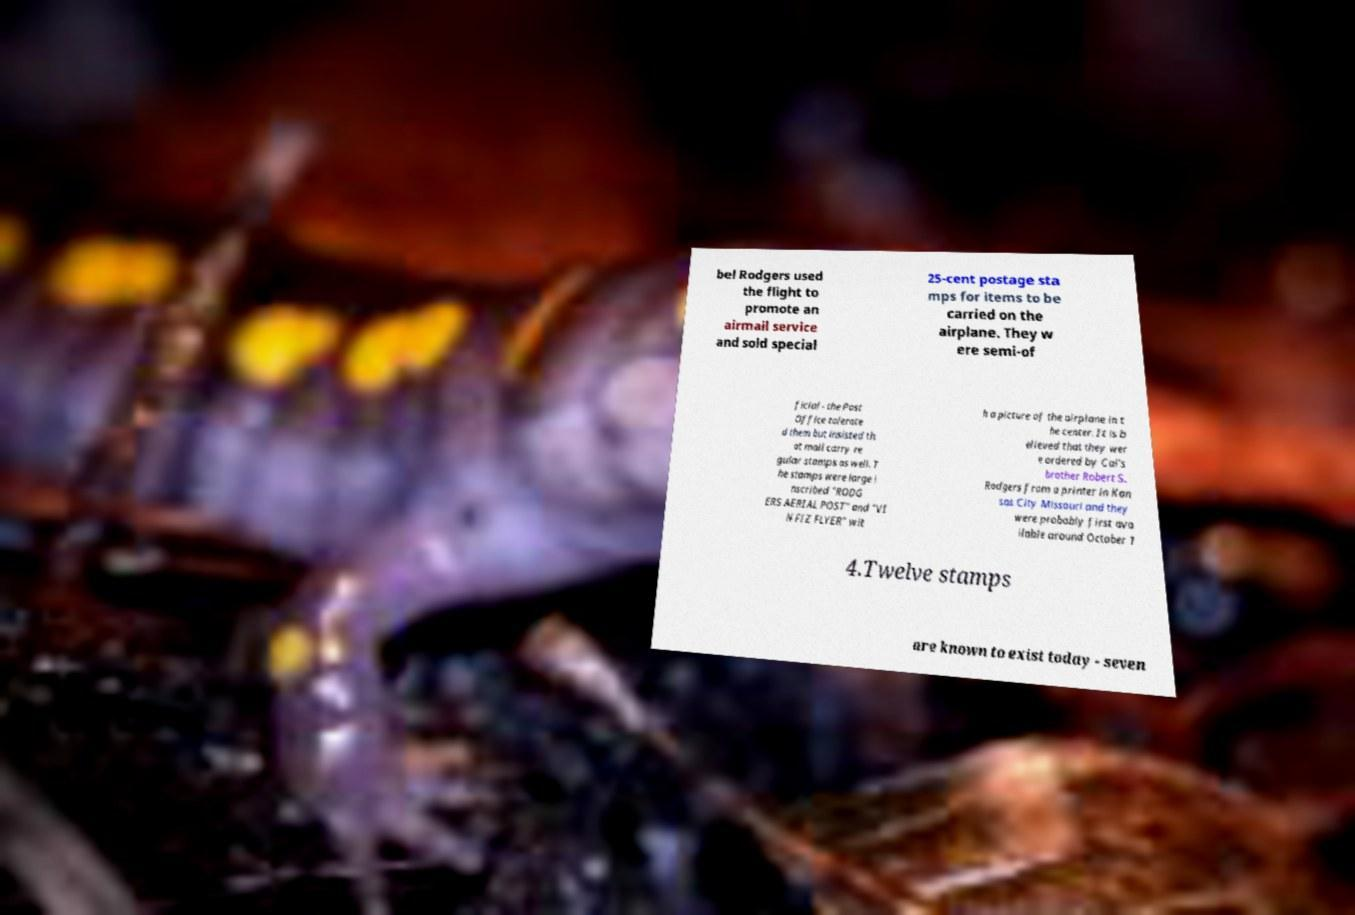Please read and relay the text visible in this image. What does it say? bel Rodgers used the flight to promote an airmail service and sold special 25-cent postage sta mps for items to be carried on the airplane. They w ere semi-of ficial - the Post Office tolerate d them but insisted th at mail carry re gular stamps as well. T he stamps were large i nscribed "RODG ERS AERIAL POST" and "VI N FIZ FLYER" wit h a picture of the airplane in t he center. It is b elieved that they wer e ordered by Cal's brother Robert S. Rodgers from a printer in Kan sas City Missouri and they were probably first ava ilable around October 1 4.Twelve stamps are known to exist today - seven 